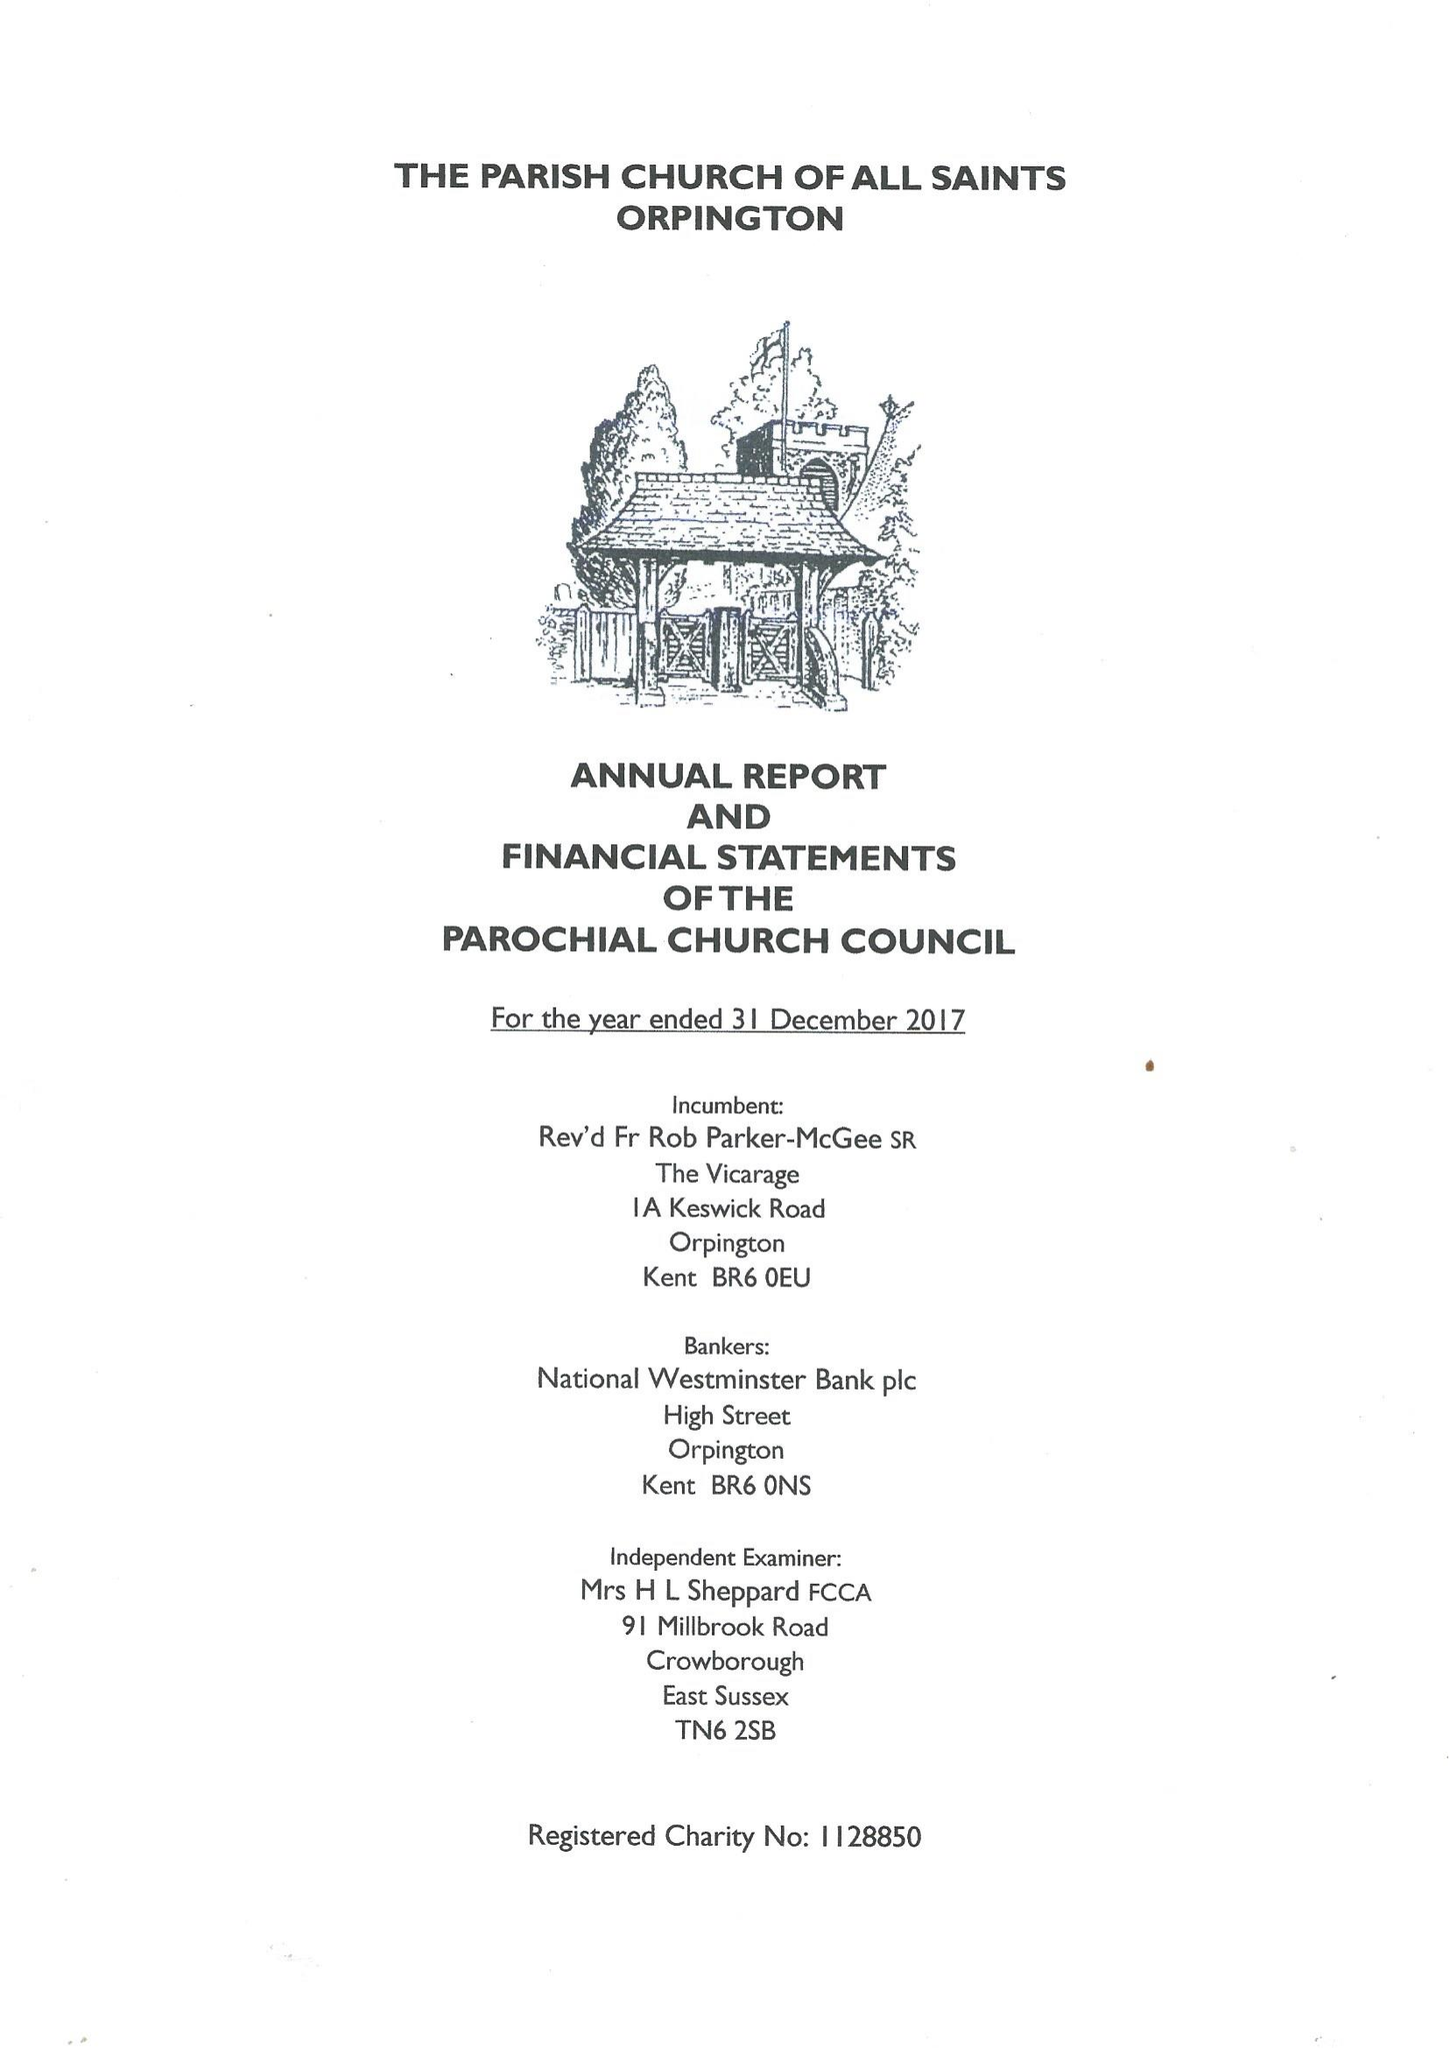What is the value for the income_annually_in_british_pounds?
Answer the question using a single word or phrase. 217517.00 